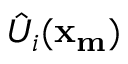Convert formula to latex. <formula><loc_0><loc_0><loc_500><loc_500>\hat { U } _ { i } ( x _ { m } )</formula> 